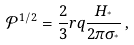<formula> <loc_0><loc_0><loc_500><loc_500>\mathcal { P } ^ { 1 / 2 } = \frac { 2 } { 3 } r q \frac { H _ { ^ { * } } } { 2 \pi \sigma _ { ^ { * } } } \, ,</formula> 